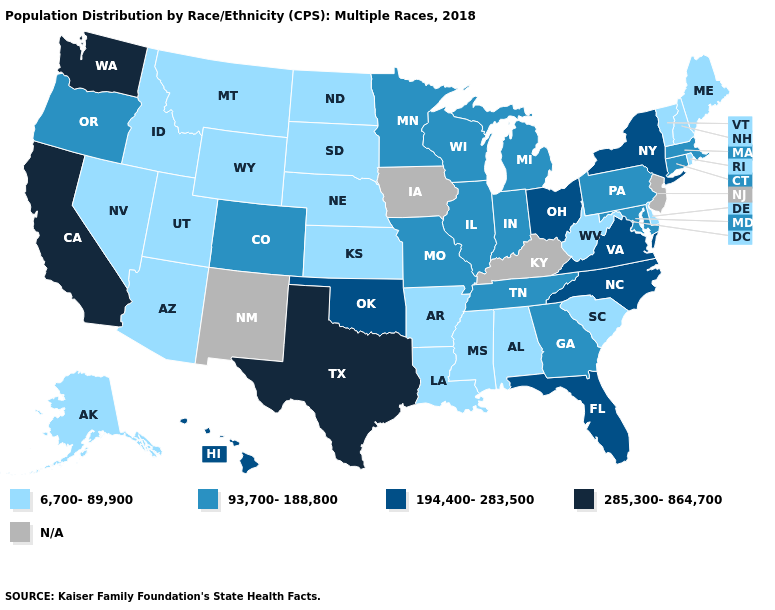Does Tennessee have the lowest value in the USA?
Keep it brief. No. Name the states that have a value in the range 285,300-864,700?
Keep it brief. California, Texas, Washington. Name the states that have a value in the range N/A?
Concise answer only. Iowa, Kentucky, New Jersey, New Mexico. Name the states that have a value in the range 6,700-89,900?
Give a very brief answer. Alabama, Alaska, Arizona, Arkansas, Delaware, Idaho, Kansas, Louisiana, Maine, Mississippi, Montana, Nebraska, Nevada, New Hampshire, North Dakota, Rhode Island, South Carolina, South Dakota, Utah, Vermont, West Virginia, Wyoming. What is the lowest value in the USA?
Write a very short answer. 6,700-89,900. What is the value of Alaska?
Answer briefly. 6,700-89,900. What is the value of Ohio?
Quick response, please. 194,400-283,500. What is the highest value in the USA?
Short answer required. 285,300-864,700. What is the lowest value in the West?
Give a very brief answer. 6,700-89,900. What is the highest value in states that border Delaware?
Keep it brief. 93,700-188,800. What is the value of Kentucky?
Quick response, please. N/A. What is the value of South Carolina?
Keep it brief. 6,700-89,900. Does Washington have the highest value in the West?
Answer briefly. Yes. Among the states that border Missouri , which have the highest value?
Give a very brief answer. Oklahoma. 